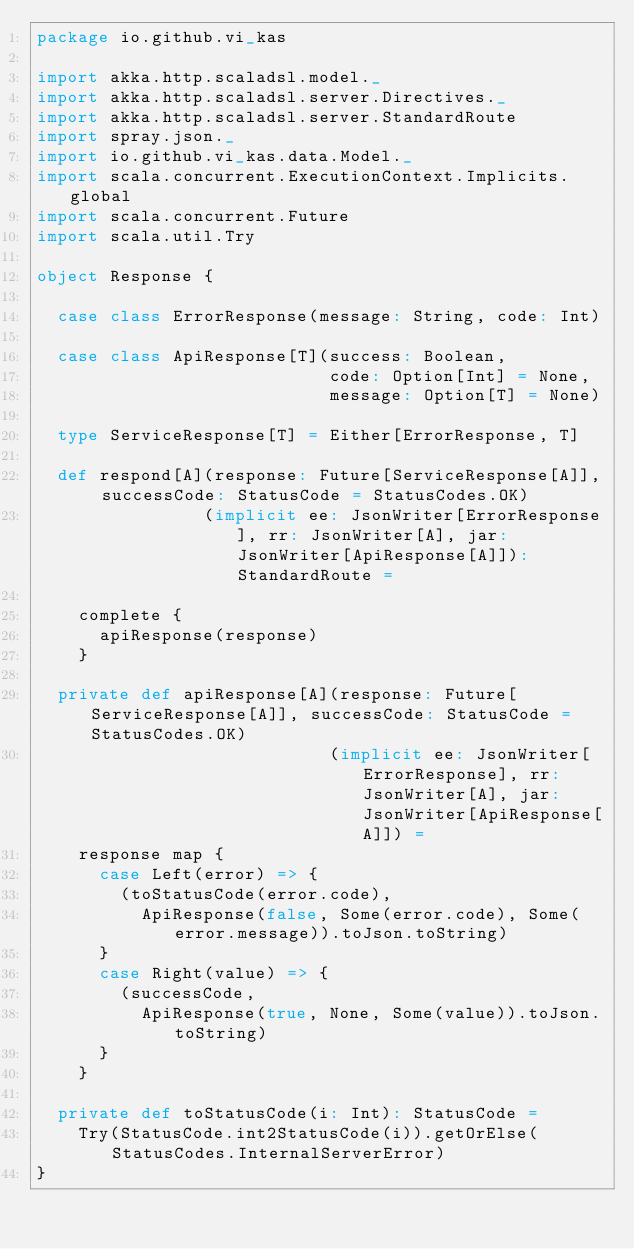Convert code to text. <code><loc_0><loc_0><loc_500><loc_500><_Scala_>package io.github.vi_kas

import akka.http.scaladsl.model._
import akka.http.scaladsl.server.Directives._
import akka.http.scaladsl.server.StandardRoute
import spray.json._
import io.github.vi_kas.data.Model._
import scala.concurrent.ExecutionContext.Implicits.global
import scala.concurrent.Future
import scala.util.Try

object Response {

  case class ErrorResponse(message: String, code: Int)

  case class ApiResponse[T](success: Boolean,
                            code: Option[Int] = None,
                            message: Option[T] = None)

  type ServiceResponse[T] = Either[ErrorResponse, T]

  def respond[A](response: Future[ServiceResponse[A]], successCode: StatusCode = StatusCodes.OK)
                (implicit ee: JsonWriter[ErrorResponse], rr: JsonWriter[A], jar: JsonWriter[ApiResponse[A]]): StandardRoute =

    complete {
      apiResponse(response)
    }

  private def apiResponse[A](response: Future[ServiceResponse[A]], successCode: StatusCode = StatusCodes.OK)
                            (implicit ee: JsonWriter[ErrorResponse], rr: JsonWriter[A], jar: JsonWriter[ApiResponse[A]]) =
    response map {
      case Left(error) => {
        (toStatusCode(error.code),
          ApiResponse(false, Some(error.code), Some(error.message)).toJson.toString)
      }
      case Right(value) => {
        (successCode,
          ApiResponse(true, None, Some(value)).toJson.toString)
      }
    }

  private def toStatusCode(i: Int): StatusCode =
    Try(StatusCode.int2StatusCode(i)).getOrElse(StatusCodes.InternalServerError)
}</code> 